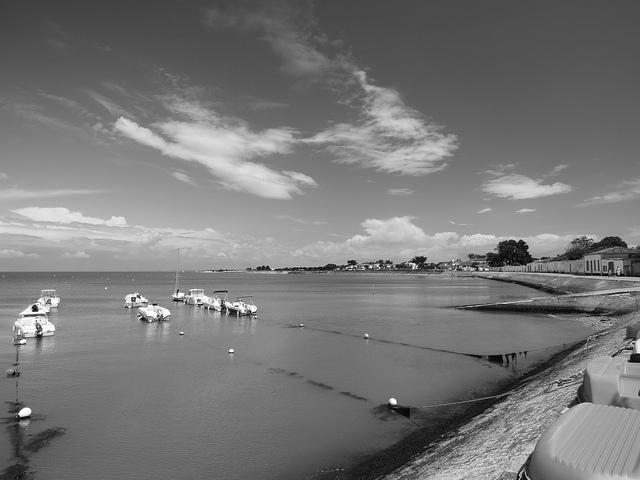What vehicles are located in the water? Please explain your reasoning. boat. Boats float in water and are a form of water transportation. 